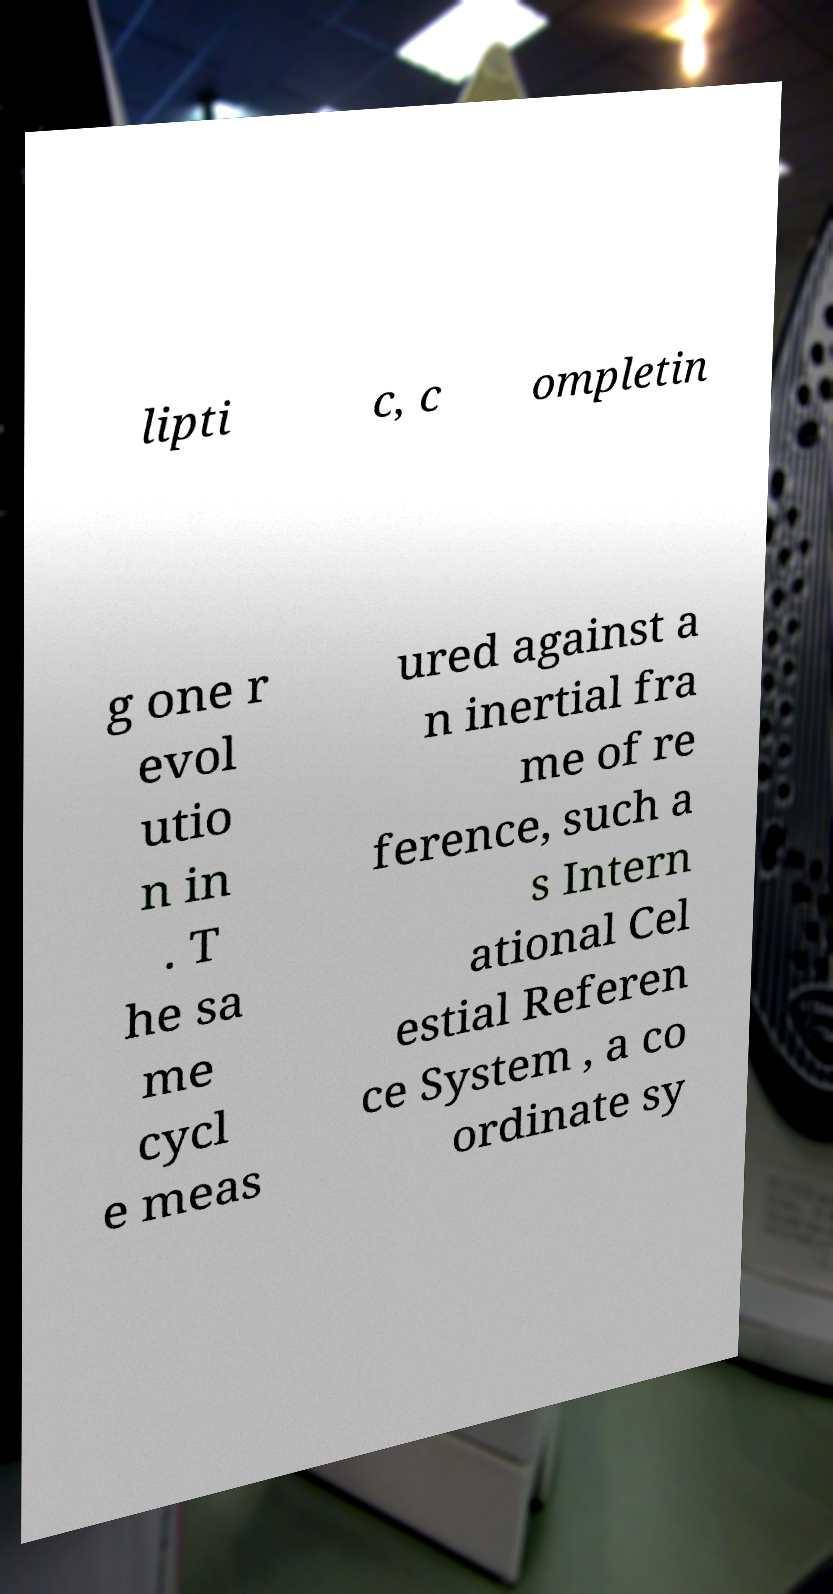What messages or text are displayed in this image? I need them in a readable, typed format. lipti c, c ompletin g one r evol utio n in . T he sa me cycl e meas ured against a n inertial fra me of re ference, such a s Intern ational Cel estial Referen ce System , a co ordinate sy 